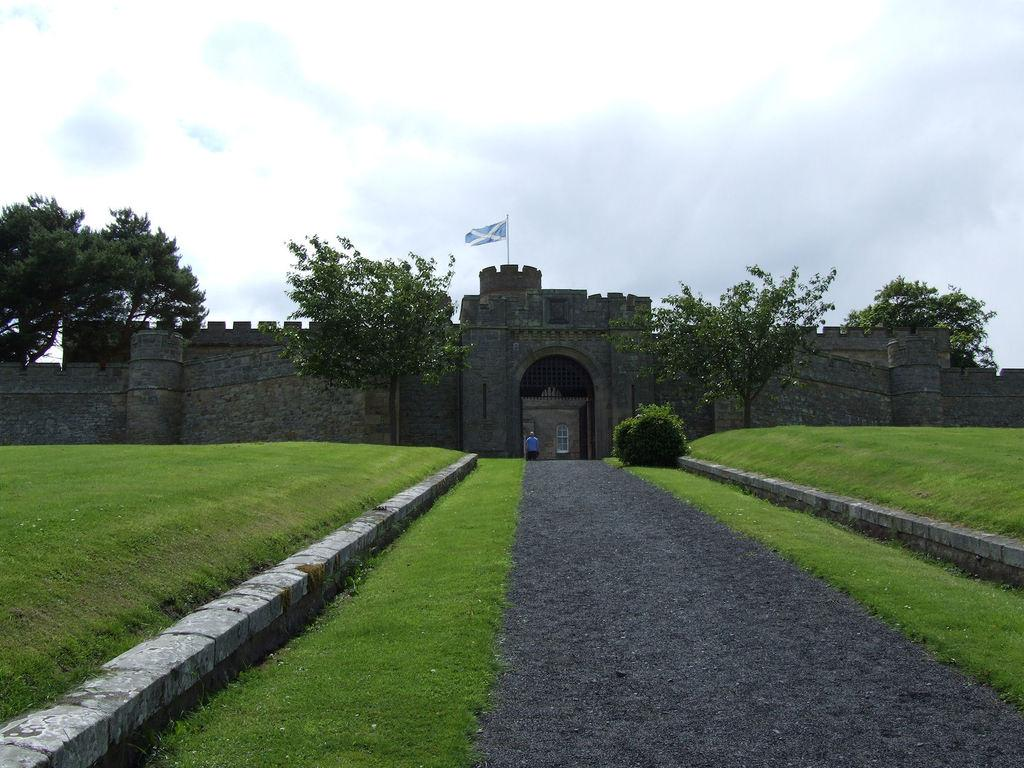What is the main structure visible in the image? There is a fort entrance in the image. Are there any people present in the image? Yes, there is a person in the image. What type of vegetation can be seen in the image? There is grass and trees in the image. What can be seen in the background of the image? The sky is visible in the background of the image. What type of dinner is being served in the image? There is no dinner present in the image; it features a fort entrance and a person. What punishment is being administered to the person in the image? There is no punishment being administered in the image; the person is simply standing near the fort entrance. 